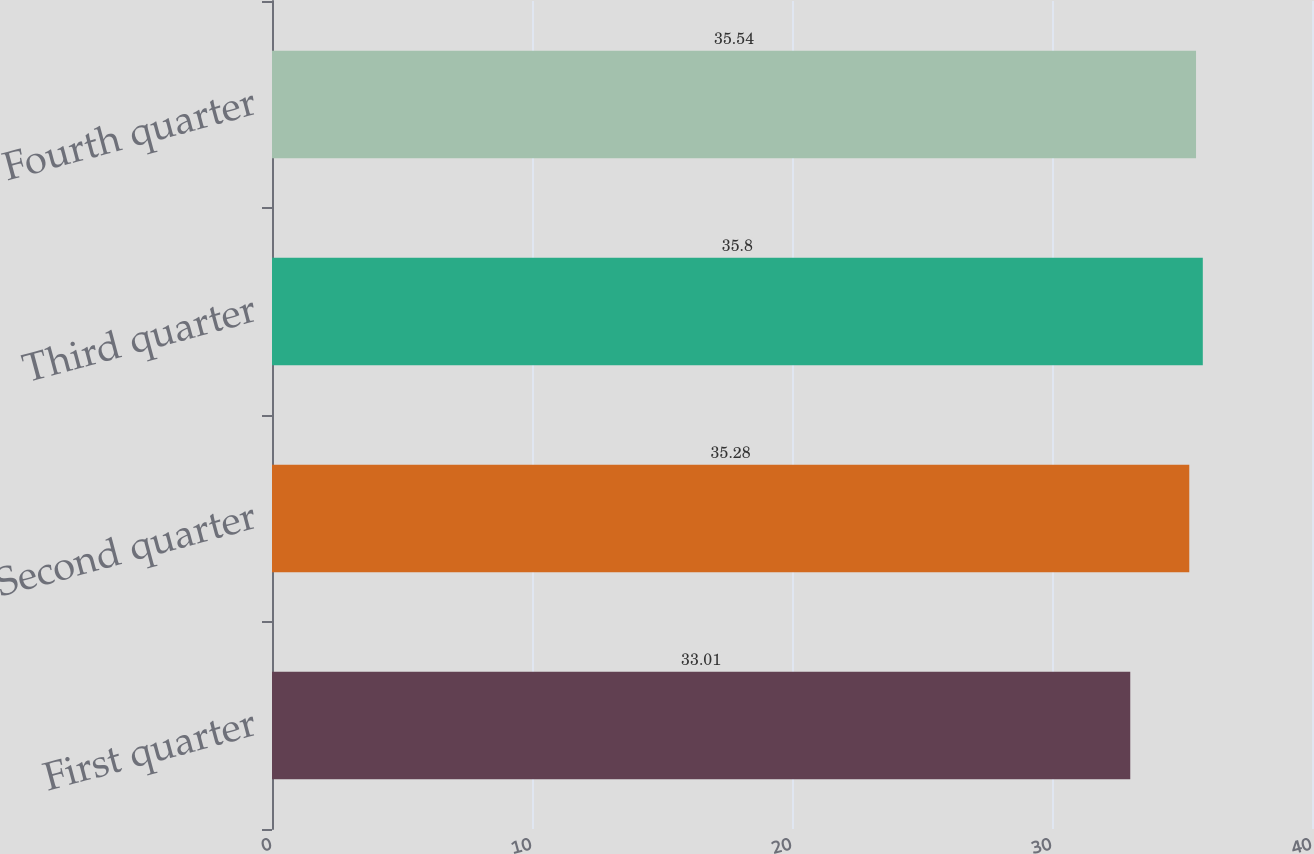<chart> <loc_0><loc_0><loc_500><loc_500><bar_chart><fcel>First quarter<fcel>Second quarter<fcel>Third quarter<fcel>Fourth quarter<nl><fcel>33.01<fcel>35.28<fcel>35.8<fcel>35.54<nl></chart> 